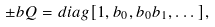Convert formula to latex. <formula><loc_0><loc_0><loc_500><loc_500>\pm b { Q } = d i a g [ 1 , b _ { 0 } , b _ { 0 } b _ { 1 } , \dots ] ,</formula> 